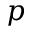<formula> <loc_0><loc_0><loc_500><loc_500>p</formula> 